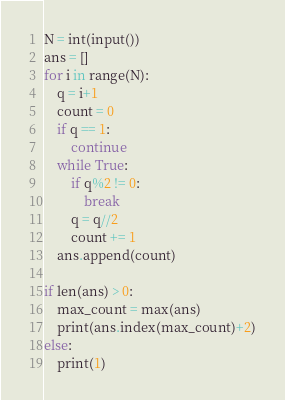<code> <loc_0><loc_0><loc_500><loc_500><_Python_>N = int(input())
ans = []
for i in range(N):
    q = i+1
    count = 0
    if q == 1:
        continue
    while True:
        if q%2 != 0:
            break
        q = q//2
        count += 1
    ans.append(count)

if len(ans) > 0:
    max_count = max(ans)
    print(ans.index(max_count)+2)
else:
    print(1)</code> 